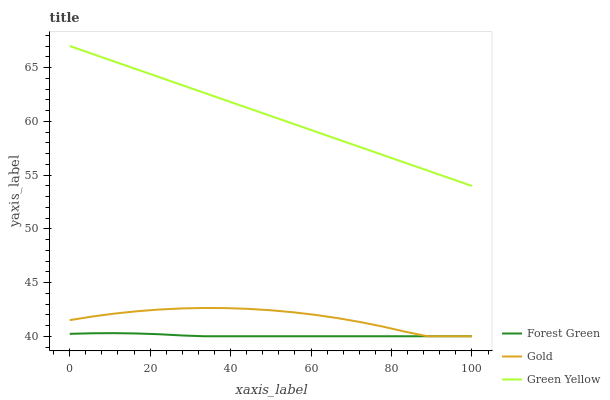Does Forest Green have the minimum area under the curve?
Answer yes or no. Yes. Does Green Yellow have the maximum area under the curve?
Answer yes or no. Yes. Does Gold have the minimum area under the curve?
Answer yes or no. No. Does Gold have the maximum area under the curve?
Answer yes or no. No. Is Green Yellow the smoothest?
Answer yes or no. Yes. Is Gold the roughest?
Answer yes or no. Yes. Is Gold the smoothest?
Answer yes or no. No. Is Green Yellow the roughest?
Answer yes or no. No. Does Forest Green have the lowest value?
Answer yes or no. Yes. Does Green Yellow have the lowest value?
Answer yes or no. No. Does Green Yellow have the highest value?
Answer yes or no. Yes. Does Gold have the highest value?
Answer yes or no. No. Is Forest Green less than Green Yellow?
Answer yes or no. Yes. Is Green Yellow greater than Gold?
Answer yes or no. Yes. Does Forest Green intersect Gold?
Answer yes or no. Yes. Is Forest Green less than Gold?
Answer yes or no. No. Is Forest Green greater than Gold?
Answer yes or no. No. Does Forest Green intersect Green Yellow?
Answer yes or no. No. 